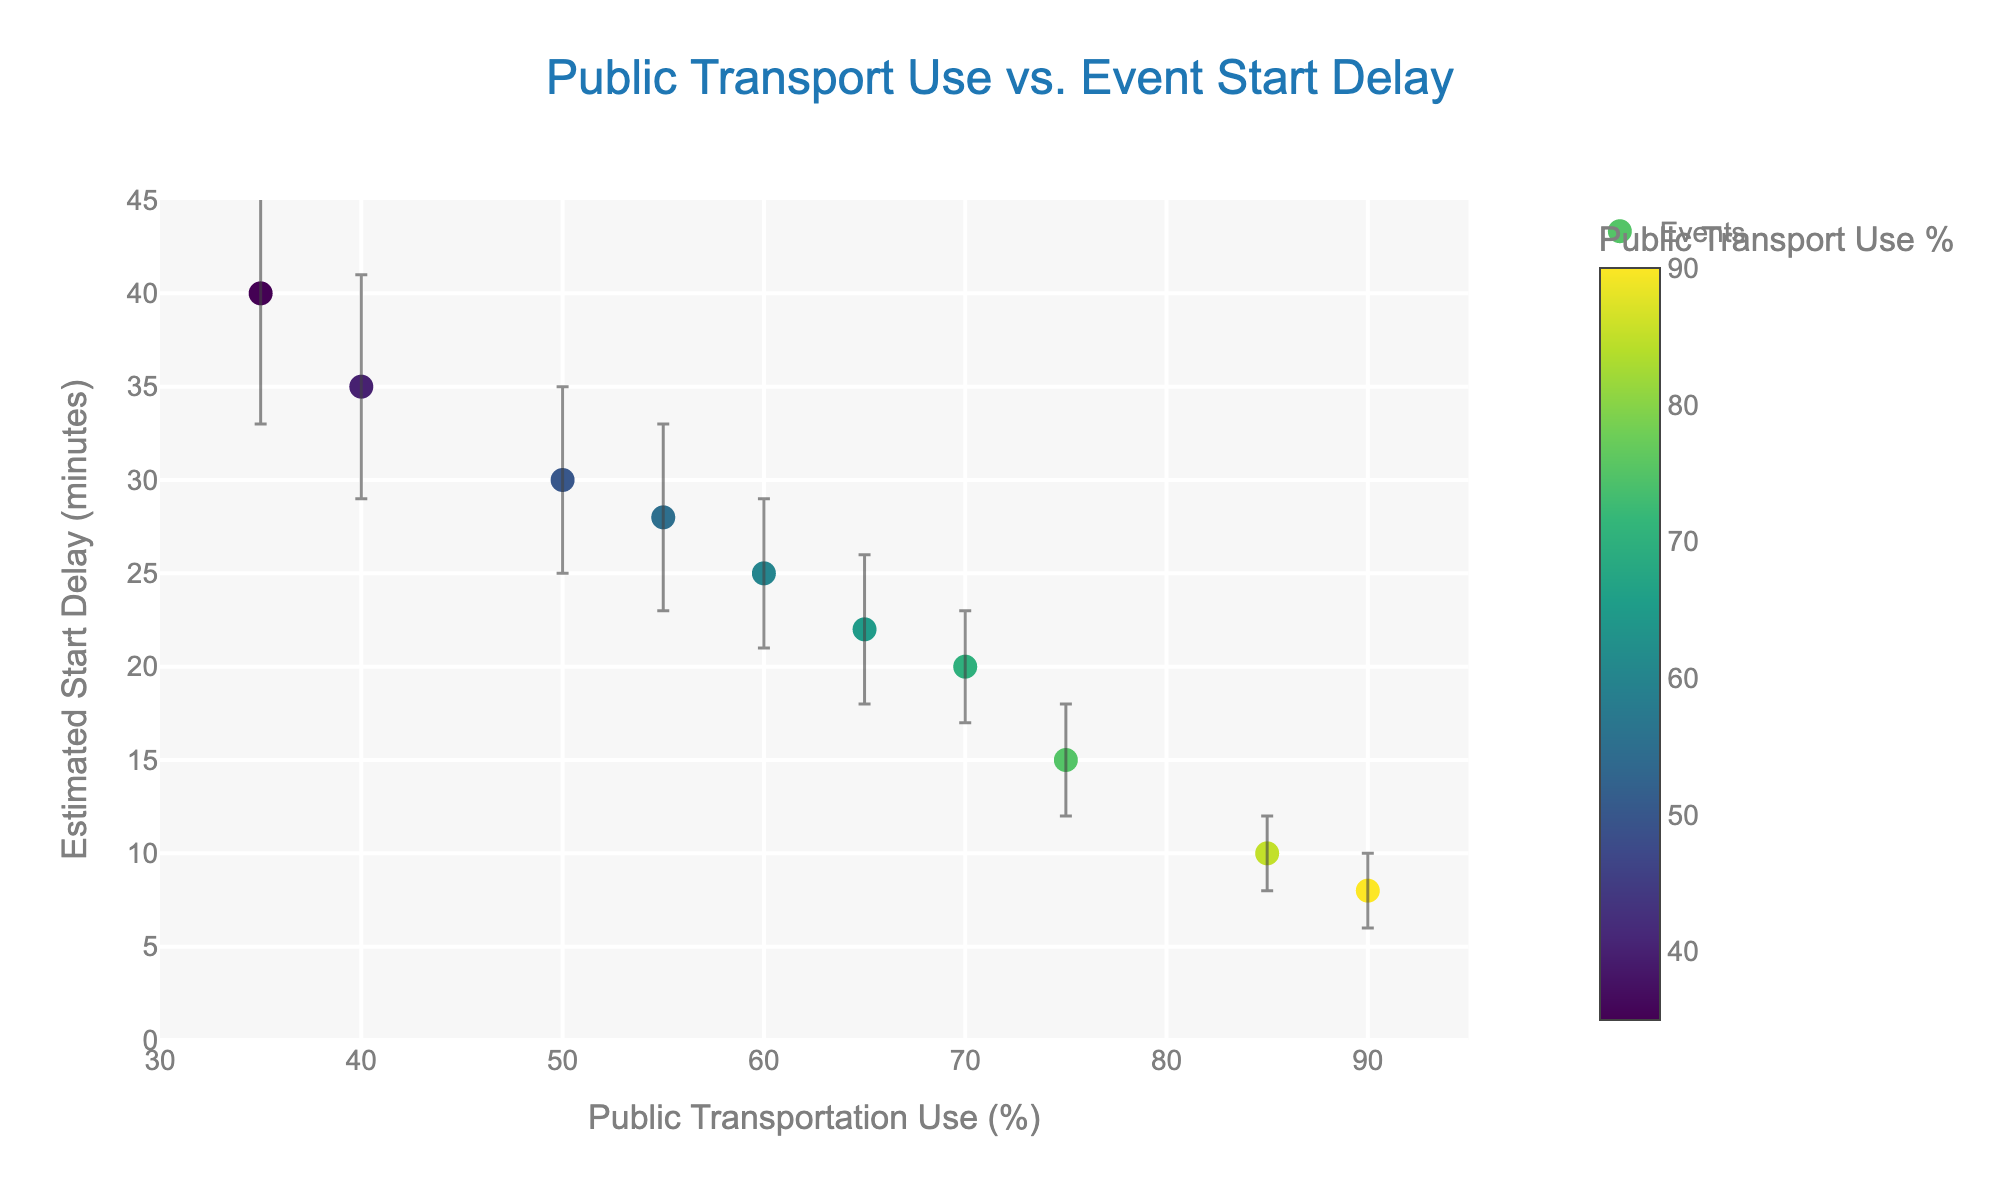What is the title of the plot? The title is displayed at the top center of the figure and provides a brief description of what the plot represents. The title is "Public Transport Use vs. Event Start Delay."
Answer: Public Transport Use vs. Event Start Delay How many events are shown in the plot? Count the number of points in the scatter plot. Each point represents a different event. There are ten points, thus ten events.
Answer: 10 Which event has the highest estimated start delay? Look for the point with the highest value on the y-axis. The Charity_Run has the highest y-value of 40 minutes.
Answer: Charity_Run What is the public transportation use percentage for the Sports Parade event? Locate the Sports_Parade event by its text label and see its corresponding x-axis value. It is at 90%.
Answer: 90% Which event has the smallest error margin? Identify the smallest vertical error bar length. The Tech_Conference and Sports_Parade both have the smallest error margin of 2 minutes.
Answer: Tech_Conference, Sports_Parade Is there any relationship between public transport use and start delay times? Examine the distribution of data points and their respective values. In general, as public transport use increases, the start delay tends to decrease, such as the comparison between Farmers_Market and Sports_Parade.
Answer: As public transport use increases, start delays tend to decrease What is the average estimated start delay time for events with over 70% public transport use? Identify events with public transport use over 70% (Music_Festival, Tech_Conference, Outdoor_Concert, Sports_Parade). Calculate their average delay time: (15 + 10 + 20 + 8) / 4 = 53 / 4 = 13.25 minutes.
Answer: 13.25 minutes Which event has the largest estimated start delay compared to its error margin? Calculate the ratio of delayed time to error margin for each event. The Charity_Run has a delay of 40 minutes and an error margin of 7, giving a ratio of approximately 5.71, the highest among others.
Answer: Charity_Run How does the estimated start delay for the Food Truck Fair compare with that of the Book Fair? Locate both points on the graph and compare their y-values. The Food_Truck_Fair (25 mins) has a slightly lower delay than the Book_Fair (22 mins).
Answer: Food Truck Fair: 25 mins vs Book Fair: 22 mins Which has a higher public transportation use percentage, the Farmers Market or the Craft Show? Compare the x-values of the Farmers_Market and Craft_Show points. Farmers_Market is at 40%, while Craft_Show is at 55%.
Answer: Craft_Show 